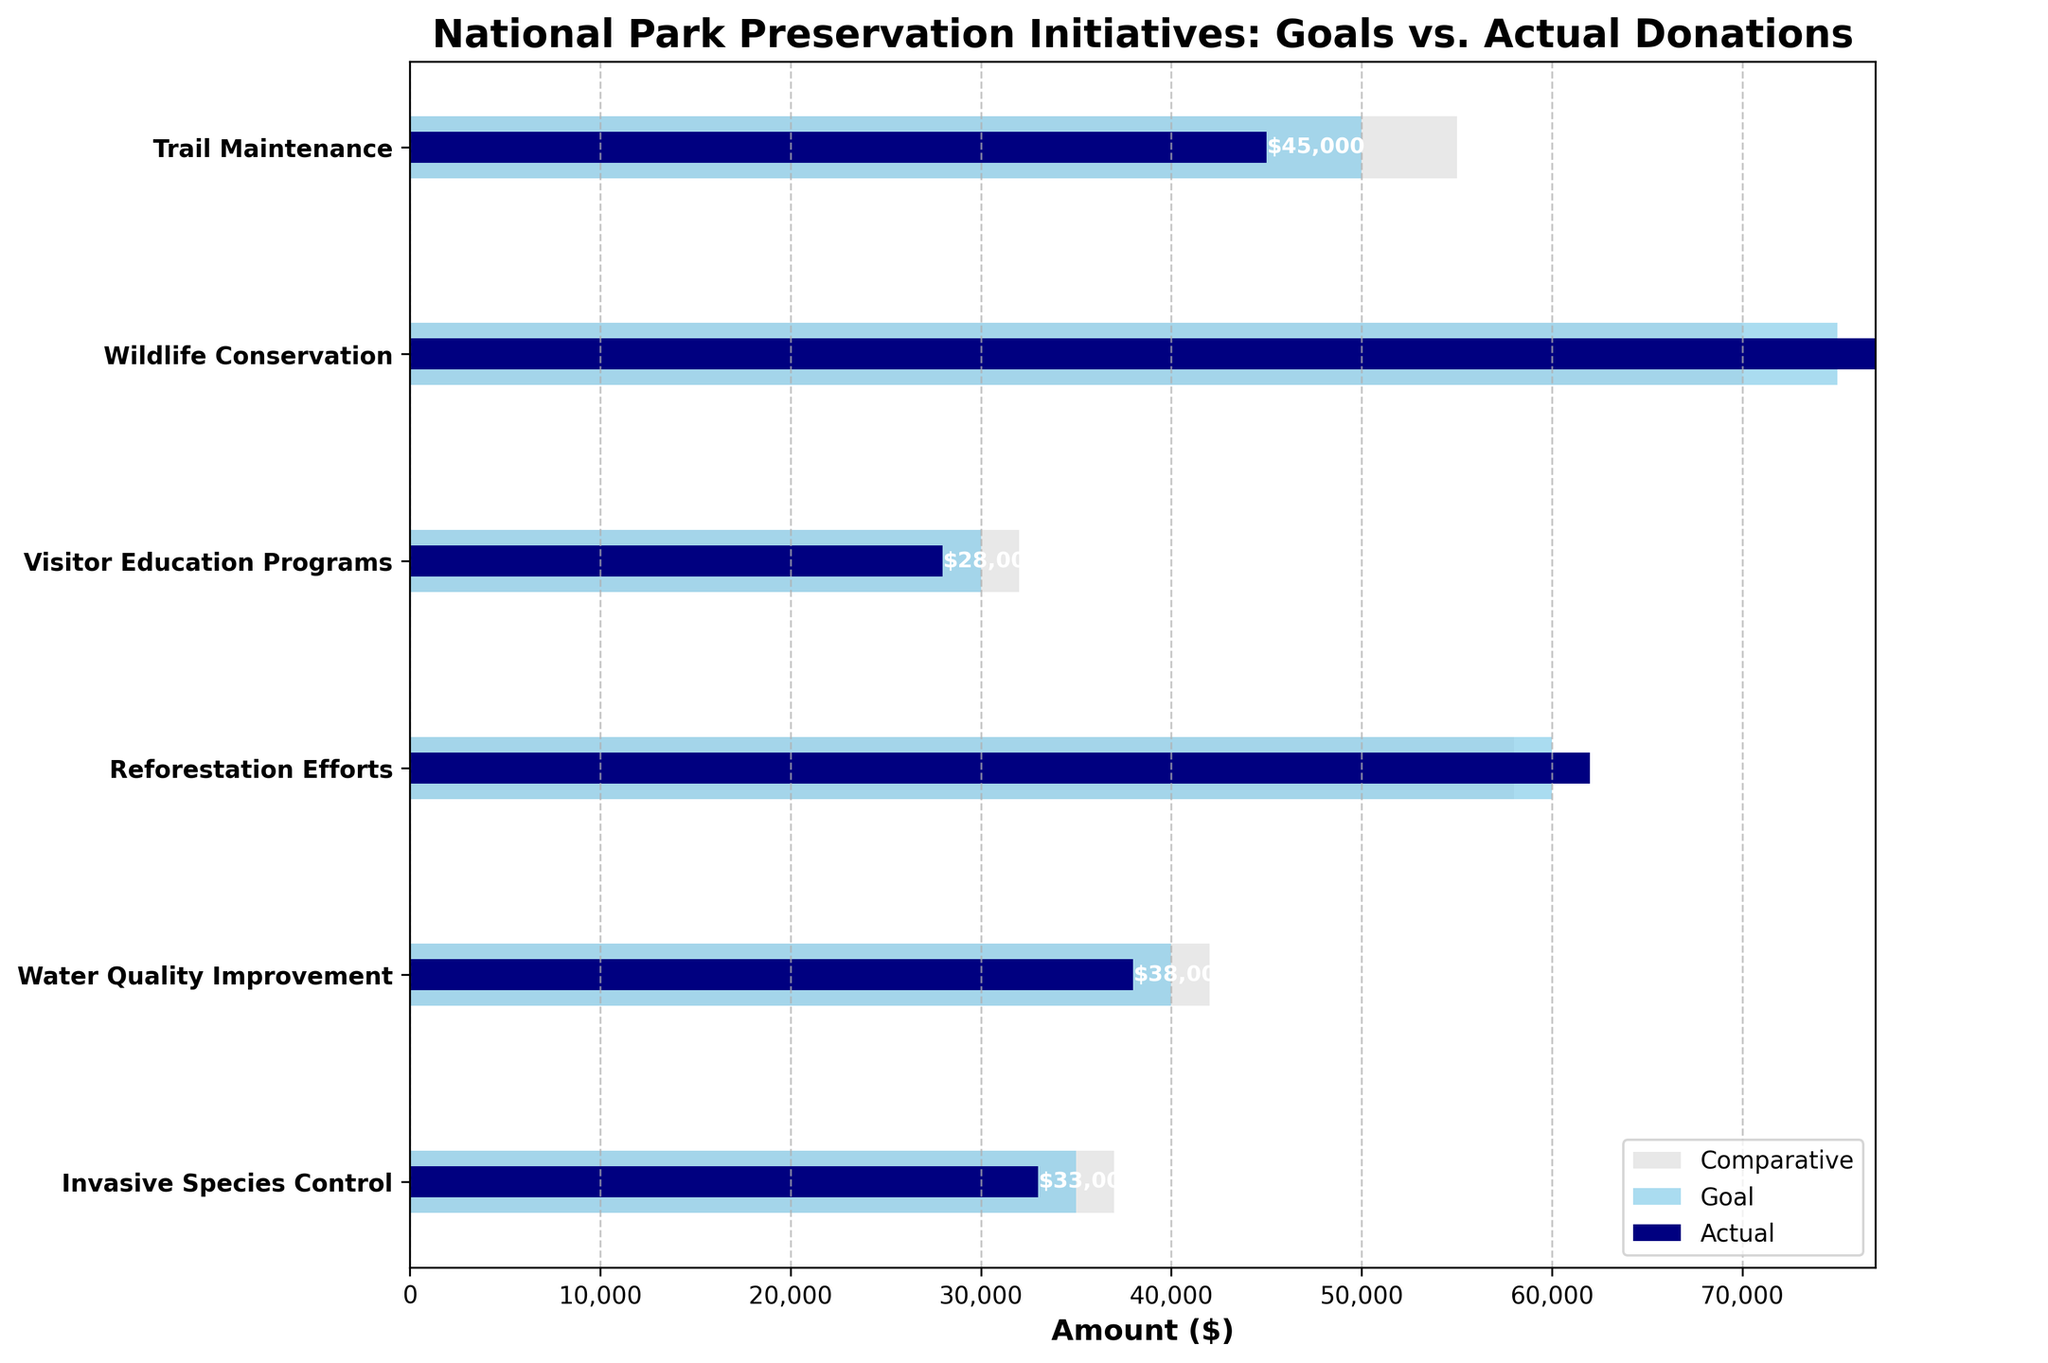What is the title of the chart? The main heading of the chart provides an overview of what the data represents. It's usually located at the top of the chart.
Answer: National Park Preservation Initiatives: Goals vs. Actual Donations Which project had the highest actual donations? To answer this, we compare the actual donation values for all projects and identify the one with the maximum value.
Answer: Wildlife Conservation Which project missed its donation goal by the largest margin? We need to find the difference between the goal and actual donations for each project, then identify the project with the largest negative difference.
Answer: Trail Maintenance How does the actual donation for Visitor Education Programs compare to its comparative value? Look at the bars representing the actual donation and the comparative value for Visitor Education Programs and compare their lengths.
Answer: The actual donation is lower than the comparative value For the project "Reforestation Efforts," by how much did actual donations exceed the goal? Subtract the goal amount from the actual donation amount for "Reforestation Efforts".
Answer: $2,000 What is the total amount of actual donations received across all projects? Sum all the actual donations values from each project to get the total actual donations.
Answer: $286,000 Which project had actual donations that were closest to the comparative value? Calculate the absolute difference between actual and comparative values for each project, then find the smallest difference.
Answer: Invasive Species Control What is the average goal amount for all projects? Sum all the goal values and then divide by the number of projects. (50,000 + 75,000 + 30,000 + 60,000 + 40,000 + 35,000) / 6
Answer: $48,333.33 How do the actual donations for Water Quality Improvement compare to its goal? Compare the actual donation amount directly with the goal amount for Water Quality Improvement.
Answer: The actual donation is less than the goal 